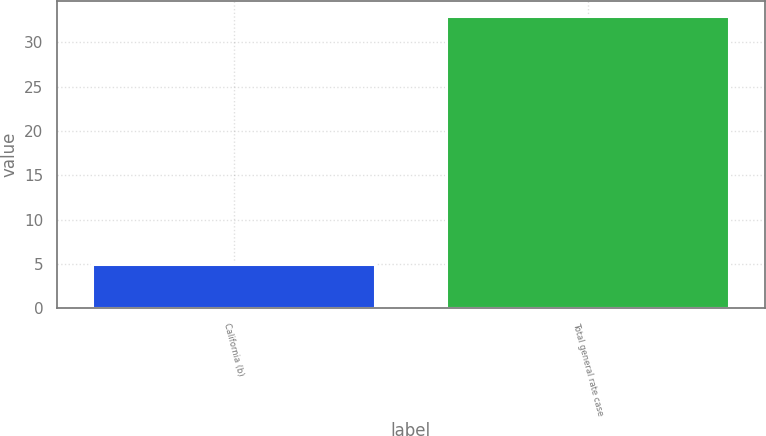Convert chart. <chart><loc_0><loc_0><loc_500><loc_500><bar_chart><fcel>California (b)<fcel>Total general rate case<nl><fcel>5<fcel>33<nl></chart> 